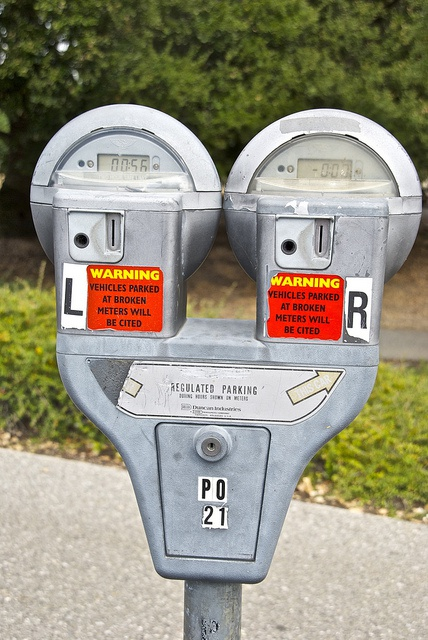Describe the objects in this image and their specific colors. I can see a parking meter in darkgreen, lightgray, darkgray, and gray tones in this image. 